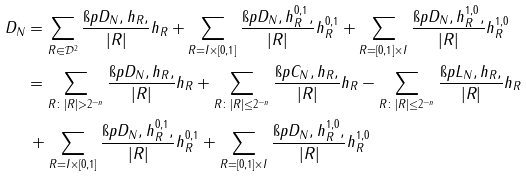<formula> <loc_0><loc_0><loc_500><loc_500>D _ { N } & = \sum _ { R \in \mathcal { D } ^ { 2 } } \frac { \i p D _ { N } , h _ { R } , } { | R | } h _ { R } + \sum _ { R = I \times [ 0 , 1 ] } \frac { \i p D _ { N } , h ^ { 0 , 1 } _ { R } , } { | R | } h ^ { 0 , 1 } _ { R } + \sum _ { R = [ 0 , 1 ] \times I } \frac { \i p D _ { N } , h ^ { 1 , 0 } _ { R } , } { | R | } h ^ { 1 , 0 } _ { R } \\ & = \sum _ { R \colon | R | > 2 ^ { - n } } \frac { \i p D _ { N } , h _ { R } , } { | R | } h _ { R } + \sum _ { R \colon | R | \leq 2 ^ { - n } } \frac { \i p C _ { N } , h _ { R } , } { | R | } h _ { R } - \sum _ { R \colon | R | \leq 2 ^ { - n } } \frac { \i p L _ { N } , h _ { R } , } { | R | } h _ { R } \\ & \, + \sum _ { R = I \times [ 0 , 1 ] } \frac { \i p D _ { N } , h ^ { 0 , 1 } _ { R } , } { | R | } h ^ { 0 , 1 } _ { R } + \sum _ { R = [ 0 , 1 ] \times I } \frac { \i p D _ { N } , h ^ { 1 , 0 } _ { R } , } { | R | } h ^ { 1 , 0 } _ { R }</formula> 